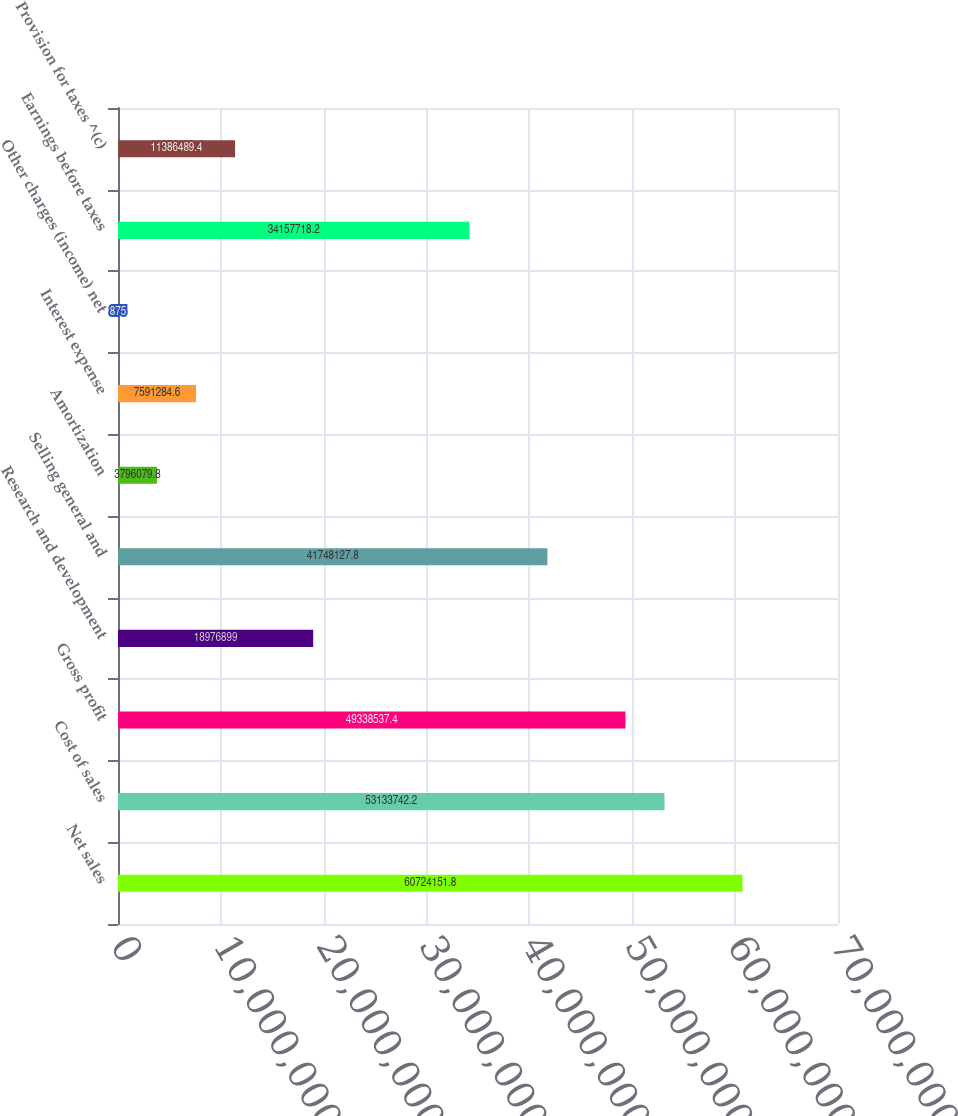Convert chart to OTSL. <chart><loc_0><loc_0><loc_500><loc_500><bar_chart><fcel>Net sales<fcel>Cost of sales<fcel>Gross profit<fcel>Research and development<fcel>Selling general and<fcel>Amortization<fcel>Interest expense<fcel>Other charges (income) net<fcel>Earnings before taxes<fcel>Provision for taxes ^(c)<nl><fcel>6.07242e+07<fcel>5.31337e+07<fcel>4.93385e+07<fcel>1.89769e+07<fcel>4.17481e+07<fcel>3.79608e+06<fcel>7.59128e+06<fcel>875<fcel>3.41577e+07<fcel>1.13865e+07<nl></chart> 